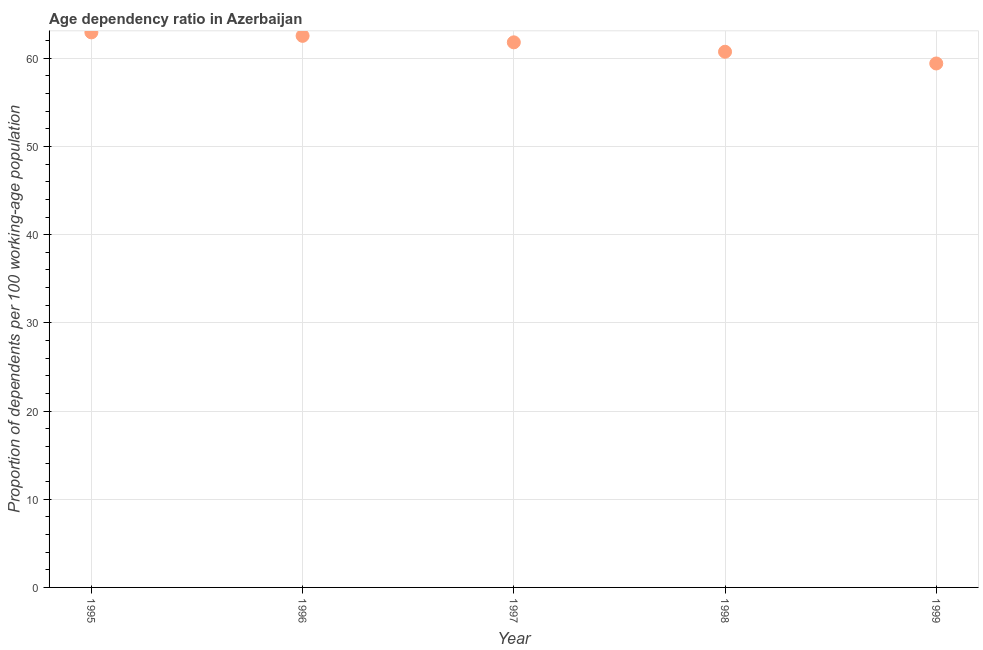What is the age dependency ratio in 1996?
Provide a short and direct response. 62.55. Across all years, what is the maximum age dependency ratio?
Give a very brief answer. 62.94. Across all years, what is the minimum age dependency ratio?
Provide a succinct answer. 59.41. In which year was the age dependency ratio maximum?
Make the answer very short. 1995. What is the sum of the age dependency ratio?
Keep it short and to the point. 307.46. What is the difference between the age dependency ratio in 1996 and 1997?
Your answer should be very brief. 0.74. What is the average age dependency ratio per year?
Give a very brief answer. 61.49. What is the median age dependency ratio?
Offer a very short reply. 61.81. In how many years, is the age dependency ratio greater than 54 ?
Your response must be concise. 5. What is the ratio of the age dependency ratio in 1995 to that in 1997?
Provide a short and direct response. 1.02. Is the age dependency ratio in 1997 less than that in 1998?
Offer a terse response. No. What is the difference between the highest and the second highest age dependency ratio?
Your answer should be compact. 0.39. Is the sum of the age dependency ratio in 1996 and 1999 greater than the maximum age dependency ratio across all years?
Offer a very short reply. Yes. What is the difference between the highest and the lowest age dependency ratio?
Offer a terse response. 3.53. How many years are there in the graph?
Provide a succinct answer. 5. Are the values on the major ticks of Y-axis written in scientific E-notation?
Your response must be concise. No. What is the title of the graph?
Keep it short and to the point. Age dependency ratio in Azerbaijan. What is the label or title of the Y-axis?
Make the answer very short. Proportion of dependents per 100 working-age population. What is the Proportion of dependents per 100 working-age population in 1995?
Ensure brevity in your answer.  62.94. What is the Proportion of dependents per 100 working-age population in 1996?
Ensure brevity in your answer.  62.55. What is the Proportion of dependents per 100 working-age population in 1997?
Give a very brief answer. 61.81. What is the Proportion of dependents per 100 working-age population in 1998?
Offer a very short reply. 60.74. What is the Proportion of dependents per 100 working-age population in 1999?
Your answer should be very brief. 59.41. What is the difference between the Proportion of dependents per 100 working-age population in 1995 and 1996?
Ensure brevity in your answer.  0.39. What is the difference between the Proportion of dependents per 100 working-age population in 1995 and 1997?
Provide a succinct answer. 1.13. What is the difference between the Proportion of dependents per 100 working-age population in 1995 and 1998?
Your answer should be very brief. 2.2. What is the difference between the Proportion of dependents per 100 working-age population in 1995 and 1999?
Your answer should be very brief. 3.53. What is the difference between the Proportion of dependents per 100 working-age population in 1996 and 1997?
Your response must be concise. 0.74. What is the difference between the Proportion of dependents per 100 working-age population in 1996 and 1998?
Ensure brevity in your answer.  1.8. What is the difference between the Proportion of dependents per 100 working-age population in 1996 and 1999?
Make the answer very short. 3.13. What is the difference between the Proportion of dependents per 100 working-age population in 1997 and 1998?
Your response must be concise. 1.07. What is the difference between the Proportion of dependents per 100 working-age population in 1997 and 1999?
Your answer should be very brief. 2.4. What is the difference between the Proportion of dependents per 100 working-age population in 1998 and 1999?
Your response must be concise. 1.33. What is the ratio of the Proportion of dependents per 100 working-age population in 1995 to that in 1997?
Provide a succinct answer. 1.02. What is the ratio of the Proportion of dependents per 100 working-age population in 1995 to that in 1998?
Provide a succinct answer. 1.04. What is the ratio of the Proportion of dependents per 100 working-age population in 1995 to that in 1999?
Ensure brevity in your answer.  1.06. What is the ratio of the Proportion of dependents per 100 working-age population in 1996 to that in 1997?
Offer a very short reply. 1.01. What is the ratio of the Proportion of dependents per 100 working-age population in 1996 to that in 1999?
Offer a very short reply. 1.05. What is the ratio of the Proportion of dependents per 100 working-age population in 1997 to that in 1998?
Keep it short and to the point. 1.02. 